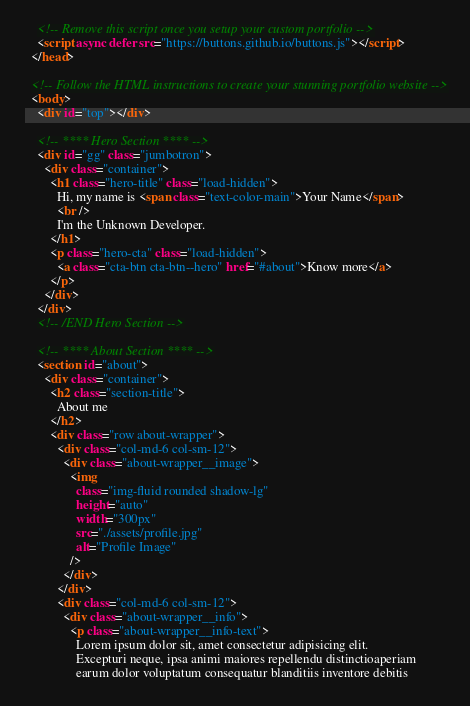Convert code to text. <code><loc_0><loc_0><loc_500><loc_500><_HTML_>
    <!-- Remove this script once you setup your custom portfolio -->
    <script async defer src="https://buttons.github.io/buttons.js"></script>
  </head>

  <!-- Follow the HTML instructions to create your stunning portfolio website -->
  <body>
    <div id="top"></div>

    <!-- **** Hero Section **** -->
    <div id="gg" class="jumbotron">
      <div class="container">
        <h1 class="hero-title" class="load-hidden">
          Hi, my name is <span class="text-color-main">Your Name</span>
          <br />
          I'm the Unknown Developer.
        </h1>
        <p class="hero-cta" class="load-hidden">
          <a class="cta-btn cta-btn--hero" href="#about">Know more</a>
        </p>
      </div>
    </div>
    <!-- /END Hero Section -->

    <!-- **** About Section **** -->
    <section id="about">
      <div class="container">
        <h2 class="section-title">
          About me
        </h2>
        <div class="row about-wrapper">
          <div class="col-md-6 col-sm-12">
            <div class="about-wrapper__image">
              <img
                class="img-fluid rounded shadow-lg"
                height="auto"
                width="300px"
                src="./assets/profile.jpg"
                alt="Profile Image"
              />
            </div>
          </div>
          <div class="col-md-6 col-sm-12">
            <div class="about-wrapper__info">
              <p class="about-wrapper__info-text">
                Lorem ipsum dolor sit, amet consectetur adipisicing elit.
                Excepturi neque, ipsa animi maiores repellendu distinctioaperiam
                earum dolor voluptatum consequatur blanditiis inventore debitis</code> 